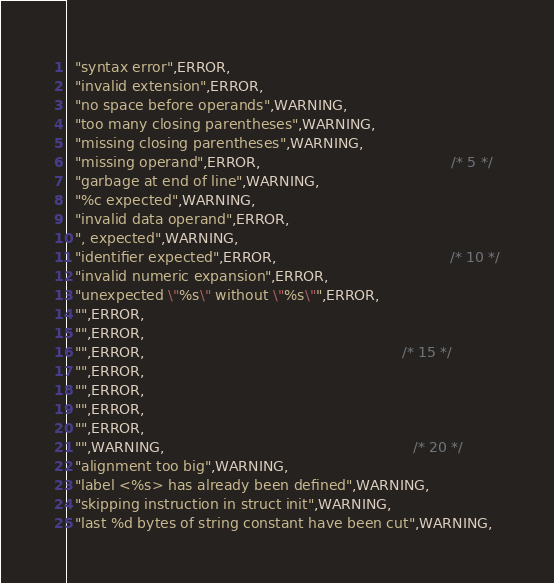<code> <loc_0><loc_0><loc_500><loc_500><_C_>  "syntax error",ERROR,
  "invalid extension",ERROR,
  "no space before operands",WARNING,
  "too many closing parentheses",WARNING,
  "missing closing parentheses",WARNING,
  "missing operand",ERROR,                                           /* 5 */
  "garbage at end of line",WARNING,
  "%c expected",WARNING,
  "invalid data operand",ERROR,
  ", expected",WARNING,
  "identifier expected",ERROR,                                       /* 10 */
  "invalid numeric expansion",ERROR,
  "unexpected \"%s\" without \"%s\"",ERROR,
  "",ERROR,
  "",ERROR,
  "",ERROR,                                                          /* 15 */
  "",ERROR,
  "",ERROR,
  "",ERROR,
  "",ERROR,
  "",WARNING,                                                        /* 20 */
  "alignment too big",WARNING,
  "label <%s> has already been defined",WARNING,
  "skipping instruction in struct init",WARNING,
  "last %d bytes of string constant have been cut",WARNING,
</code> 